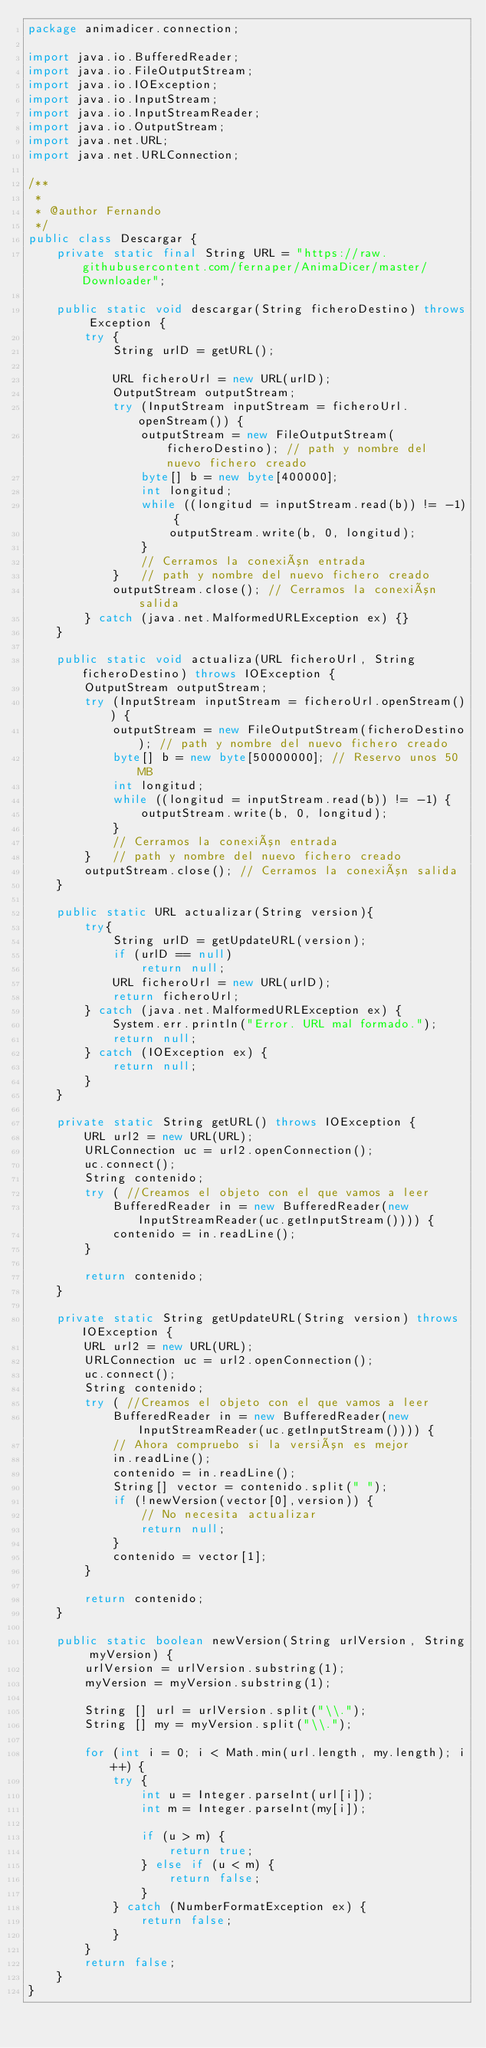Convert code to text. <code><loc_0><loc_0><loc_500><loc_500><_Java_>package animadicer.connection;

import java.io.BufferedReader;
import java.io.FileOutputStream;
import java.io.IOException;
import java.io.InputStream;
import java.io.InputStreamReader;
import java.io.OutputStream;
import java.net.URL;
import java.net.URLConnection;

/**
 *
 * @author Fernando
 */
public class Descargar {
    private static final String URL = "https://raw.githubusercontent.com/fernaper/AnimaDicer/master/Downloader";
    
    public static void descargar(String ficheroDestino) throws Exception {
        try {
            String urlD = getURL();

            URL ficheroUrl = new URL(urlD);
            OutputStream outputStream;
            try (InputStream inputStream = ficheroUrl.openStream()) {
                outputStream = new FileOutputStream(ficheroDestino); // path y nombre del nuevo fichero creado
                byte[] b = new byte[400000];
                int longitud;
                while ((longitud = inputStream.read(b)) != -1) {
                    outputStream.write(b, 0, longitud);
                }
                // Cerramos la conexión entrada
            }   // path y nombre del nuevo fichero creado
            outputStream.close(); // Cerramos la conexión salida
        } catch (java.net.MalformedURLException ex) {}
    }
    
    public static void actualiza(URL ficheroUrl, String ficheroDestino) throws IOException {
        OutputStream outputStream;
        try (InputStream inputStream = ficheroUrl.openStream()) {
            outputStream = new FileOutputStream(ficheroDestino); // path y nombre del nuevo fichero creado
            byte[] b = new byte[50000000]; // Reservo unos 50 MB
            int longitud;
            while ((longitud = inputStream.read(b)) != -1) {
                outputStream.write(b, 0, longitud);
            }
            // Cerramos la conexión entrada
        }   // path y nombre del nuevo fichero creado
        outputStream.close(); // Cerramos la conexión salida
    }
    
    public static URL actualizar(String version){
        try{
            String urlD = getUpdateURL(version);
            if (urlD == null)
                return null;
            URL ficheroUrl = new URL(urlD);
            return ficheroUrl;
        } catch (java.net.MalformedURLException ex) {
            System.err.println("Error. URL mal formado.");
            return null;
        } catch (IOException ex) {
            return null;
        }
    }
    
    private static String getURL() throws IOException {
        URL url2 = new URL(URL);
        URLConnection uc = url2.openConnection();
        uc.connect();
        String contenido;
        try ( //Creamos el objeto con el que vamos a leer
            BufferedReader in = new BufferedReader(new InputStreamReader(uc.getInputStream()))) {
            contenido = in.readLine();
        }

        return contenido;
    }
    
    private static String getUpdateURL(String version) throws IOException {
        URL url2 = new URL(URL);
        URLConnection uc = url2.openConnection();
        uc.connect();
        String contenido;
        try ( //Creamos el objeto con el que vamos a leer
            BufferedReader in = new BufferedReader(new InputStreamReader(uc.getInputStream()))) {
            // Ahora compruebo si la versión es mejor
            in.readLine();
            contenido = in.readLine();
            String[] vector = contenido.split(" ");
            if (!newVersion(vector[0],version)) {
                // No necesita actualizar
                return null;
            }
            contenido = vector[1];
        }
        
        return contenido;
    }
    
    public static boolean newVersion(String urlVersion, String myVersion) {
        urlVersion = urlVersion.substring(1);
        myVersion = myVersion.substring(1);
        
        String [] url = urlVersion.split("\\.");
        String [] my = myVersion.split("\\.");
        
        for (int i = 0; i < Math.min(url.length, my.length); i++) {
            try {
                int u = Integer.parseInt(url[i]);
                int m = Integer.parseInt(my[i]);

                if (u > m) {
                    return true;
                } else if (u < m) {
                    return false;
                }
            } catch (NumberFormatException ex) {
                return false;
            }
        }
        return false;
    }
}
</code> 